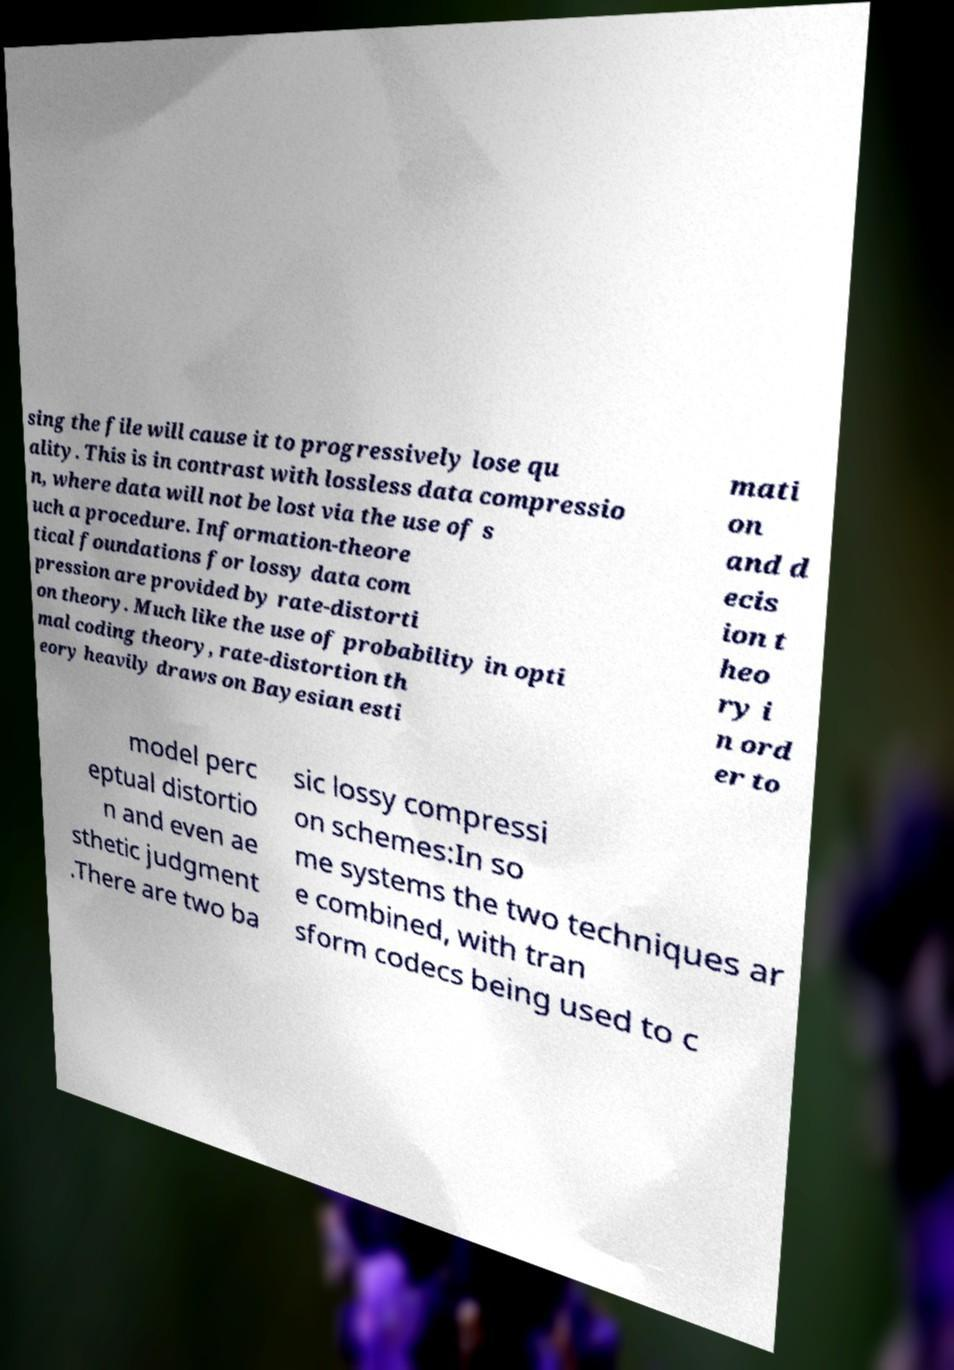Could you extract and type out the text from this image? sing the file will cause it to progressively lose qu ality. This is in contrast with lossless data compressio n, where data will not be lost via the use of s uch a procedure. Information-theore tical foundations for lossy data com pression are provided by rate-distorti on theory. Much like the use of probability in opti mal coding theory, rate-distortion th eory heavily draws on Bayesian esti mati on and d ecis ion t heo ry i n ord er to model perc eptual distortio n and even ae sthetic judgment .There are two ba sic lossy compressi on schemes:In so me systems the two techniques ar e combined, with tran sform codecs being used to c 